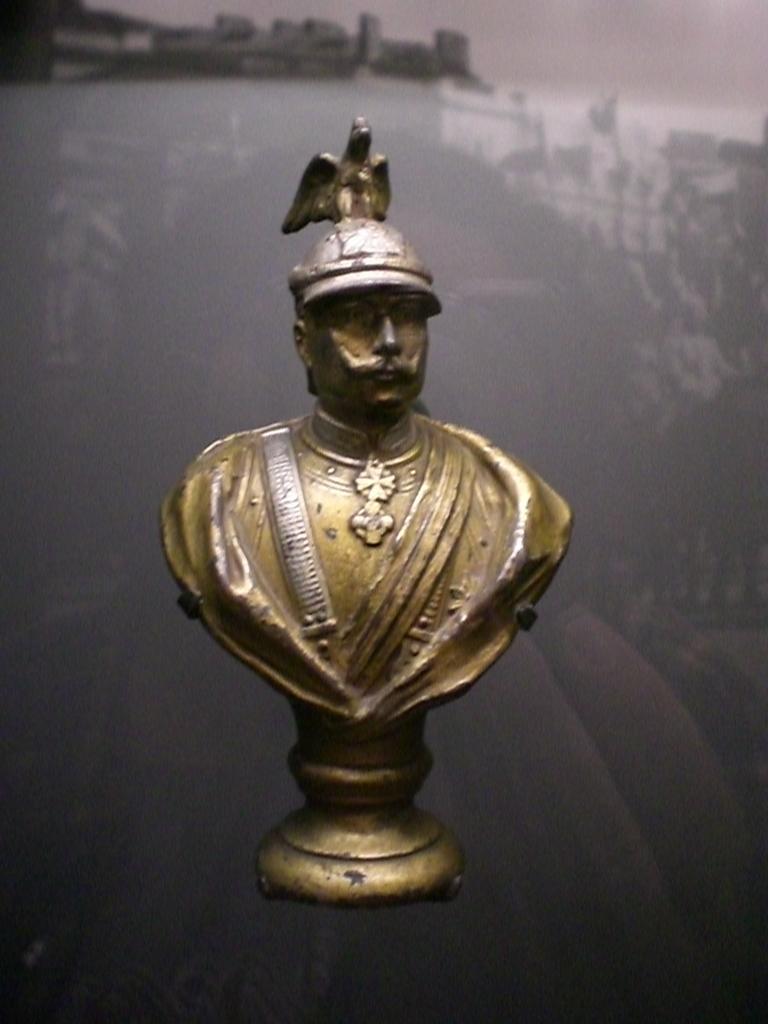Describe this image in one or two sentences. In this image we can see a bronze sculpture and in the background we can see a reflection of buildings on the glass. 